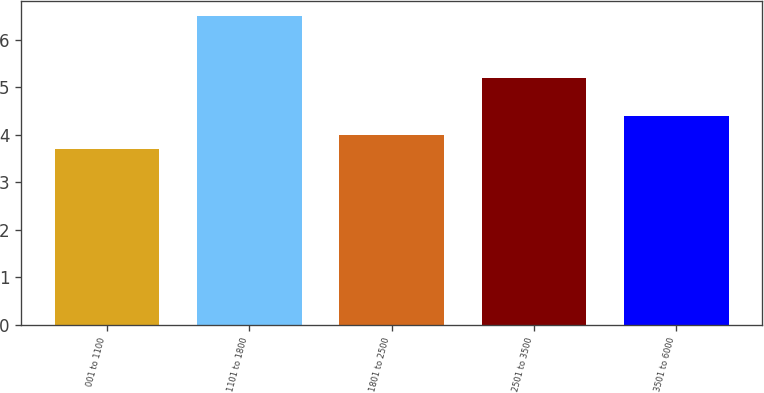Convert chart. <chart><loc_0><loc_0><loc_500><loc_500><bar_chart><fcel>001 to 1100<fcel>1101 to 1800<fcel>1801 to 2500<fcel>2501 to 3500<fcel>3501 to 6000<nl><fcel>3.7<fcel>6.5<fcel>4<fcel>5.2<fcel>4.4<nl></chart> 